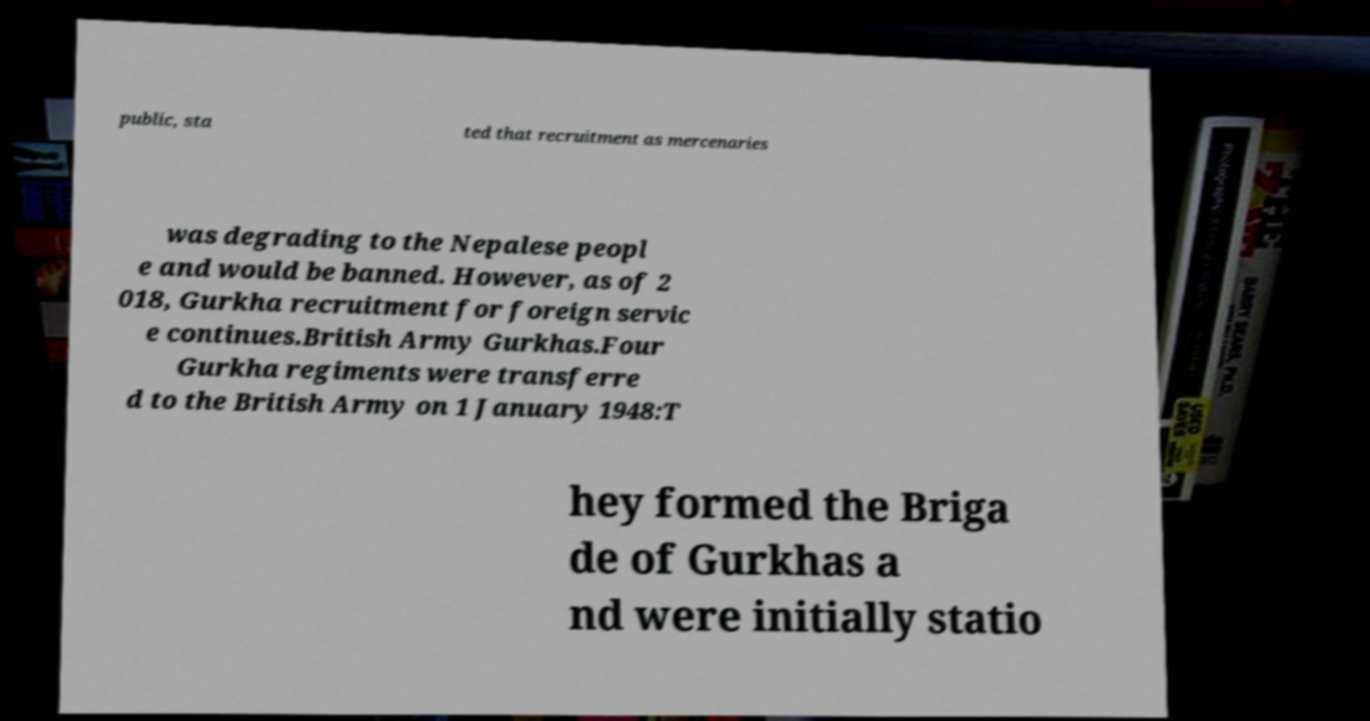Could you extract and type out the text from this image? public, sta ted that recruitment as mercenaries was degrading to the Nepalese peopl e and would be banned. However, as of 2 018, Gurkha recruitment for foreign servic e continues.British Army Gurkhas.Four Gurkha regiments were transferre d to the British Army on 1 January 1948:T hey formed the Briga de of Gurkhas a nd were initially statio 